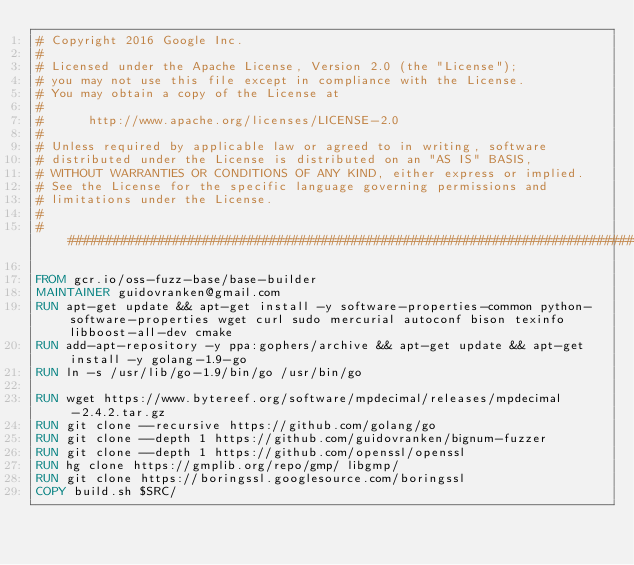<code> <loc_0><loc_0><loc_500><loc_500><_Dockerfile_># Copyright 2016 Google Inc.
#
# Licensed under the Apache License, Version 2.0 (the "License");
# you may not use this file except in compliance with the License.
# You may obtain a copy of the License at
#
#      http://www.apache.org/licenses/LICENSE-2.0
#
# Unless required by applicable law or agreed to in writing, software
# distributed under the License is distributed on an "AS IS" BASIS,
# WITHOUT WARRANTIES OR CONDITIONS OF ANY KIND, either express or implied.
# See the License for the specific language governing permissions and
# limitations under the License.
#
################################################################################

FROM gcr.io/oss-fuzz-base/base-builder
MAINTAINER guidovranken@gmail.com
RUN apt-get update && apt-get install -y software-properties-common python-software-properties wget curl sudo mercurial autoconf bison texinfo libboost-all-dev cmake
RUN add-apt-repository -y ppa:gophers/archive && apt-get update && apt-get install -y golang-1.9-go
RUN ln -s /usr/lib/go-1.9/bin/go /usr/bin/go

RUN wget https://www.bytereef.org/software/mpdecimal/releases/mpdecimal-2.4.2.tar.gz
RUN git clone --recursive https://github.com/golang/go
RUN git clone --depth 1 https://github.com/guidovranken/bignum-fuzzer
RUN git clone --depth 1 https://github.com/openssl/openssl
RUN hg clone https://gmplib.org/repo/gmp/ libgmp/
RUN git clone https://boringssl.googlesource.com/boringssl
COPY build.sh $SRC/
</code> 